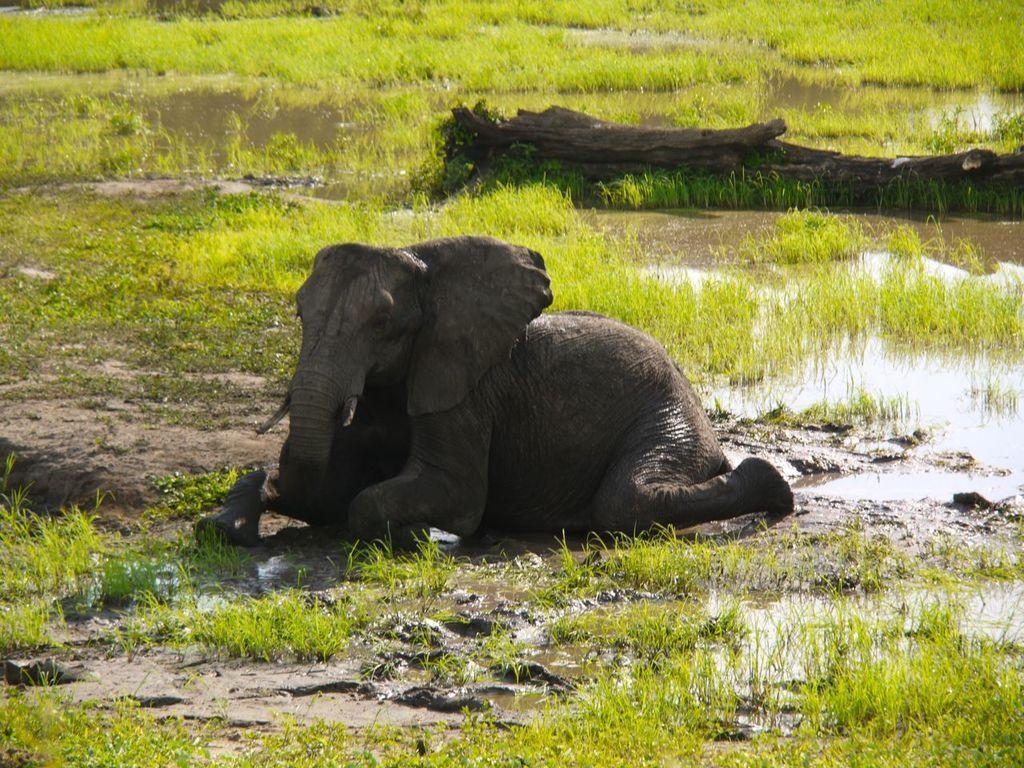What animal can be seen in the image? There is an elephant in the image. What is the position of the elephant in the image? The elephant is sitting on the ground. What type of environment is depicted in the image? There is water and grass visible in the image. Can you describe any notable features of the environment? There is a broken tree in the image. What type of sign can be seen hanging from the elephant's trunk in the image? There is no sign present in the image; the elephant is simply sitting on the ground. 